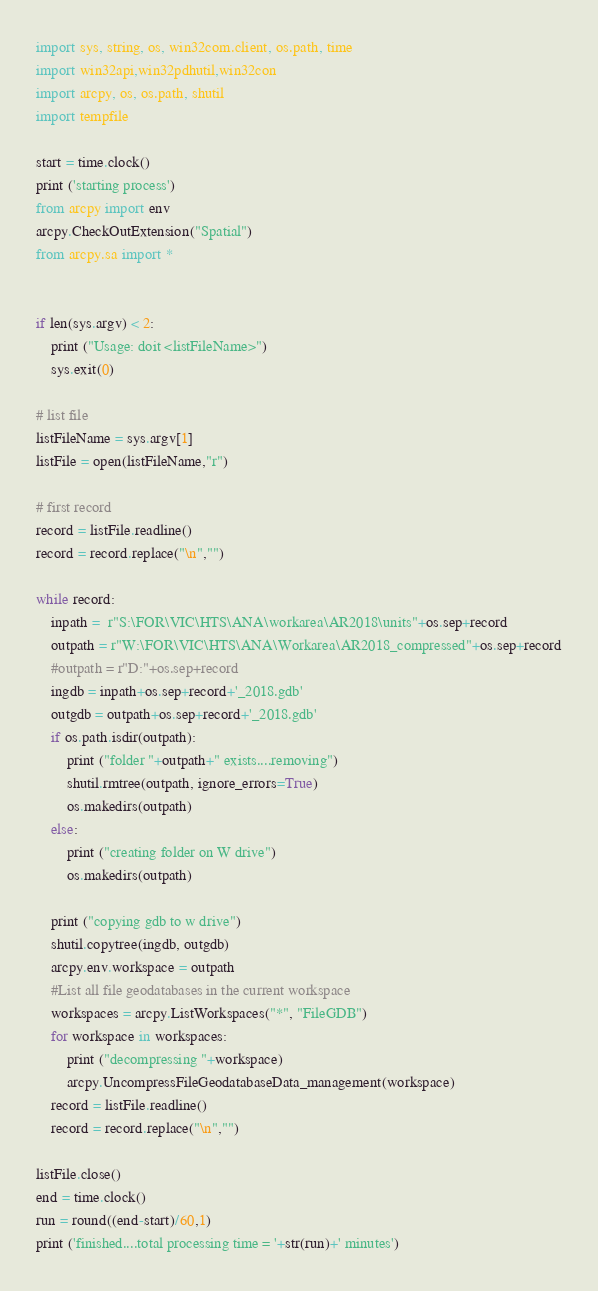Convert code to text. <code><loc_0><loc_0><loc_500><loc_500><_Python_>import sys, string, os, win32com.client, os.path, time
import win32api,win32pdhutil,win32con
import arcpy, os, os.path, shutil
import tempfile

start = time.clock()
print ('starting process')
from arcpy import env
arcpy.CheckOutExtension("Spatial")
from arcpy.sa import *


if len(sys.argv) < 2:
    print ("Usage: doit <listFileName>")
    sys.exit(0)

# list file
listFileName = sys.argv[1]
listFile = open(listFileName,"r")

# first record
record = listFile.readline()
record = record.replace("\n","")

while record:
    inpath =  r"S:\FOR\VIC\HTS\ANA\workarea\AR2018\units"+os.sep+record
    outpath = r"W:\FOR\VIC\HTS\ANA\Workarea\AR2018_compressed"+os.sep+record
    #outpath = r"D:"+os.sep+record
    ingdb = inpath+os.sep+record+'_2018.gdb'
    outgdb = outpath+os.sep+record+'_2018.gdb'
    if os.path.isdir(outpath):
        print ("folder "+outpath+" exists....removing")
        shutil.rmtree(outpath, ignore_errors=True)
        os.makedirs(outpath)
    else:
        print ("creating folder on W drive")
        os.makedirs(outpath)

    print ("copying gdb to w drive")
    shutil.copytree(ingdb, outgdb)
    arcpy.env.workspace = outpath
    #List all file geodatabases in the current workspace
    workspaces = arcpy.ListWorkspaces("*", "FileGDB")
    for workspace in workspaces:
        print ("decompressing "+workspace)
        arcpy.UncompressFileGeodatabaseData_management(workspace)
    record = listFile.readline()
    record = record.replace("\n","")

listFile.close()
end = time.clock()
run = round((end-start)/60,1)
print ('finished....total processing time = '+str(run)+' minutes')
</code> 